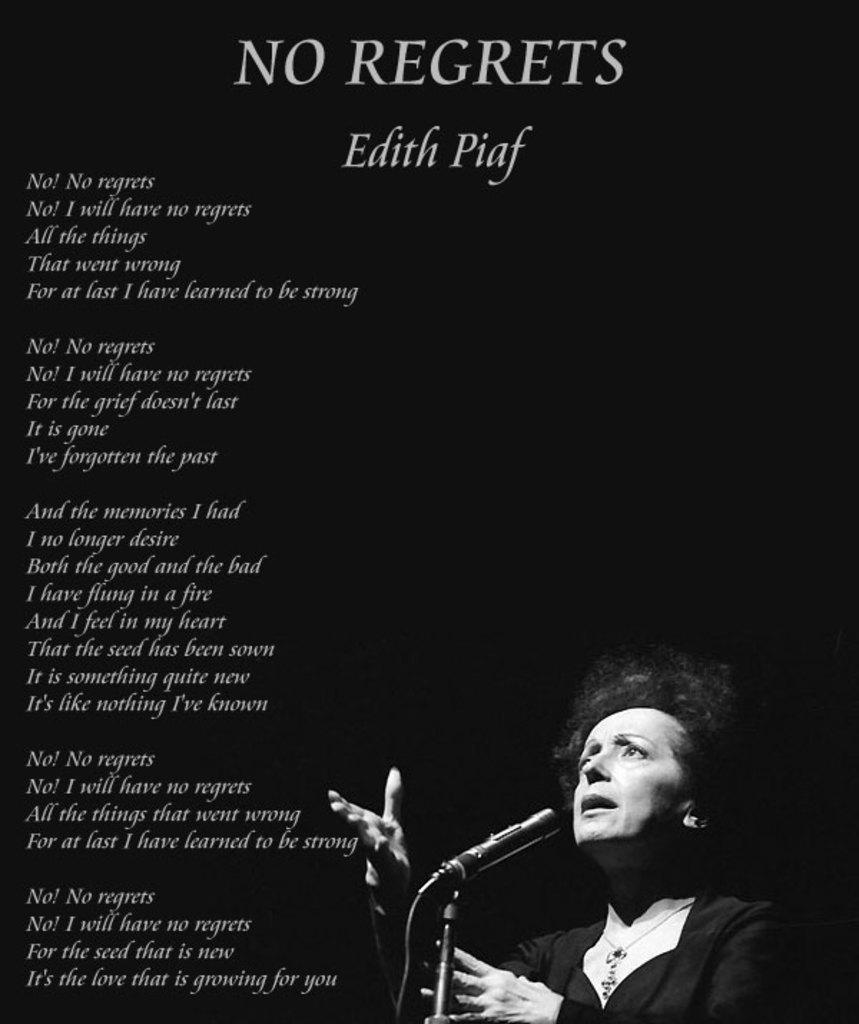What is the main object in the image? There is a banner in the image. What is depicted on the banner? There is a woman wearing a white dress on the banner. What can be seen near the banner in the image? There is a microphone (mic) in the image. What information is provided on the banner? There is text or writing on the banner. How many pears are hanging from the banner in the image? There are no pears present in the image; the banner features a woman wearing a white dress and text or writing. 